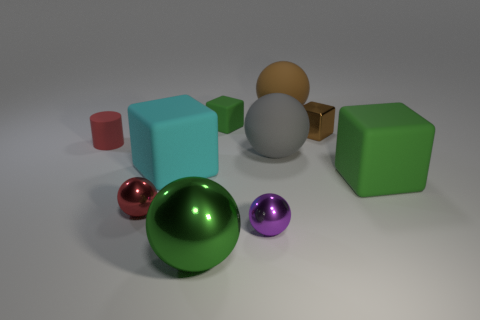How many objects are there in total, and can you describe their colors and textures? There are seven objects in total. From left to right, we have a small red cylinder with a smooth surface, a medium turquoise cube with a matte finish, a large green cube with a slightly rough texture, a purple metallic ball with a shiny surface, a large green reflective sphere, a beige cube with a matte finish, and a small brown sphere with a glossy texture. 